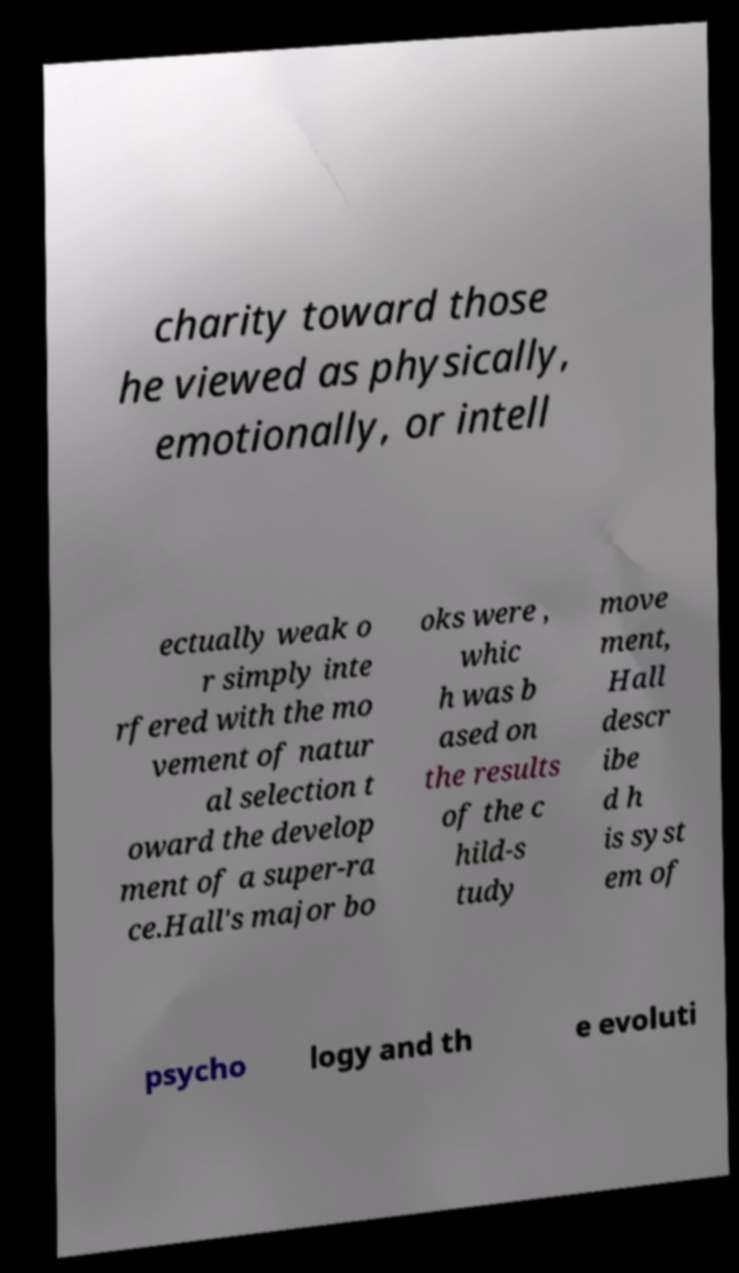I need the written content from this picture converted into text. Can you do that? charity toward those he viewed as physically, emotionally, or intell ectually weak o r simply inte rfered with the mo vement of natur al selection t oward the develop ment of a super-ra ce.Hall's major bo oks were , whic h was b ased on the results of the c hild-s tudy move ment, Hall descr ibe d h is syst em of psycho logy and th e evoluti 